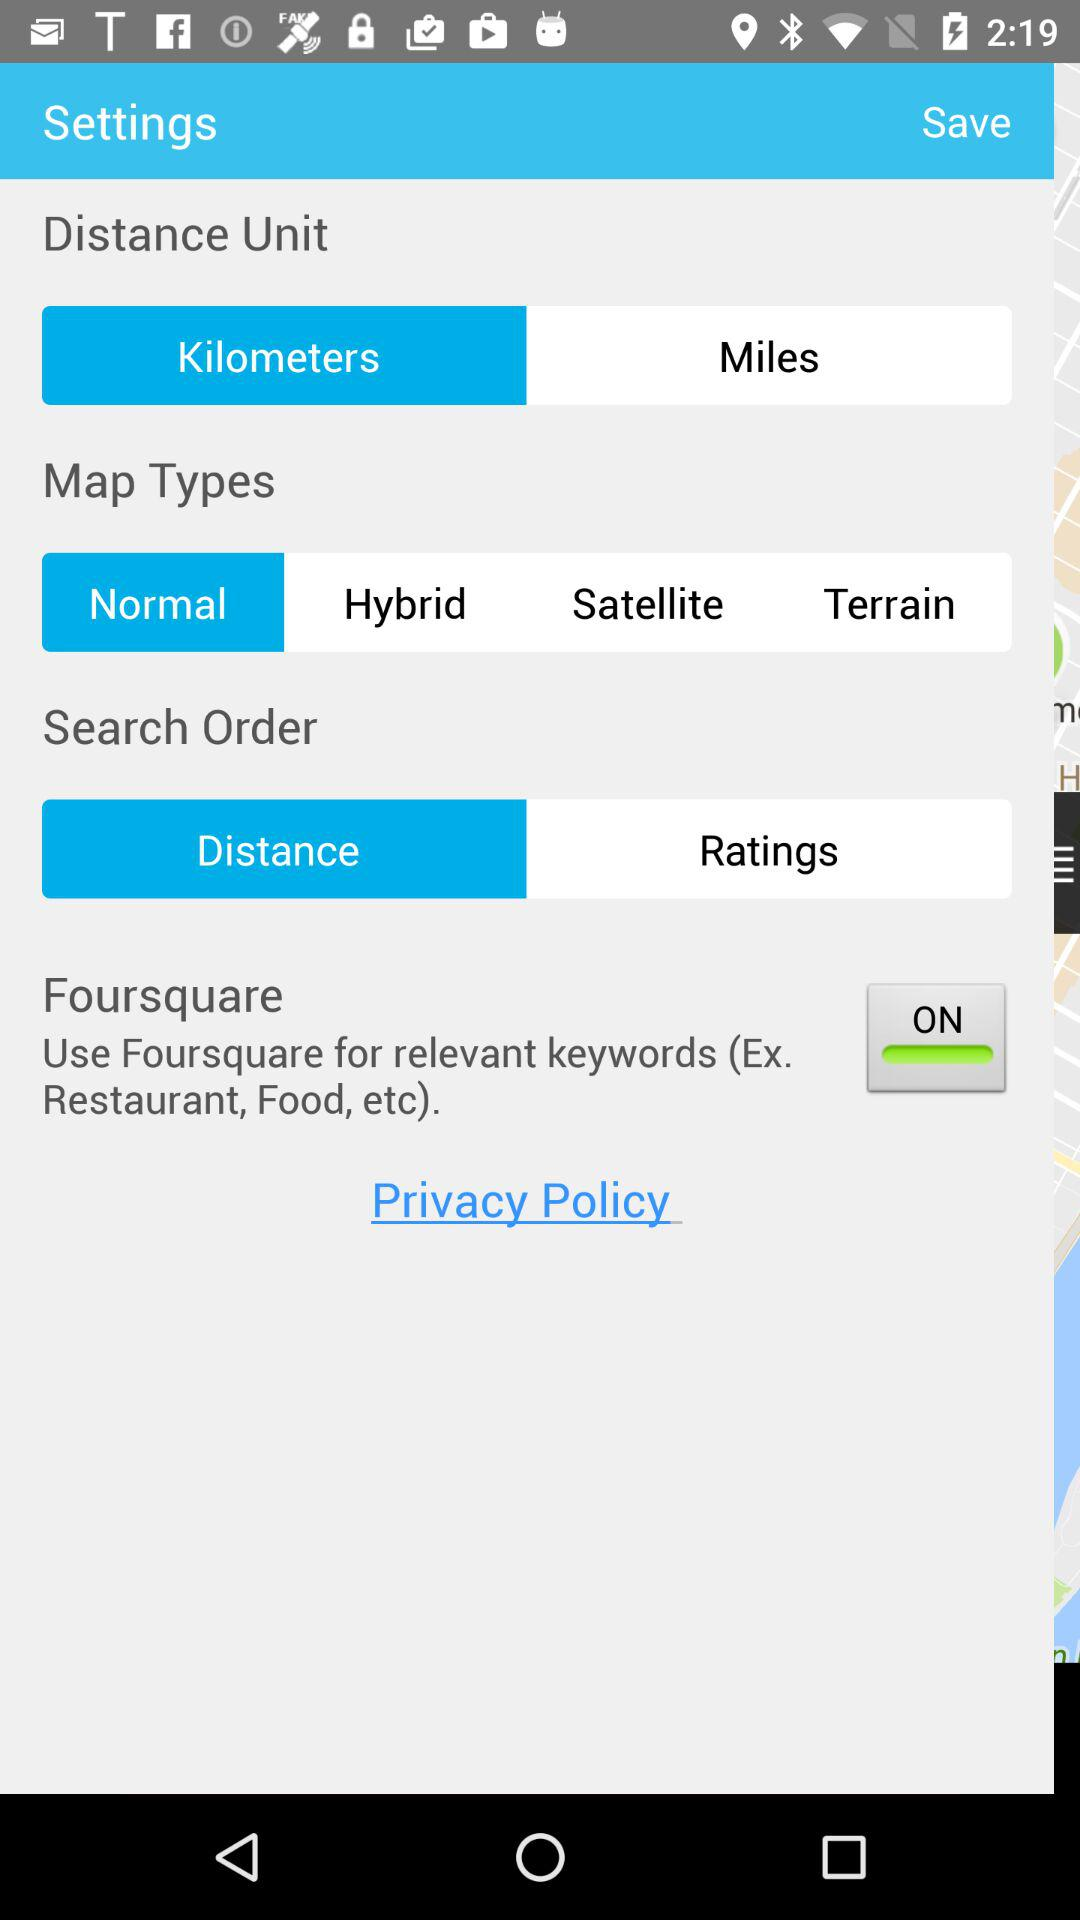What is selected in "Search Order"? The option selected in "Search Order" is "Distance". 